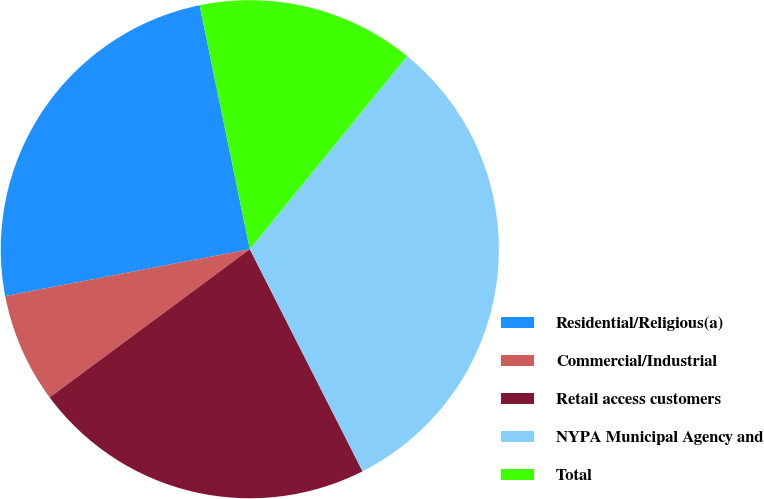<chart> <loc_0><loc_0><loc_500><loc_500><pie_chart><fcel>Residential/Religious(a)<fcel>Commercial/Industrial<fcel>Retail access customers<fcel>NYPA Municipal Agency and<fcel>Total<nl><fcel>24.78%<fcel>7.13%<fcel>22.33%<fcel>31.64%<fcel>14.11%<nl></chart> 